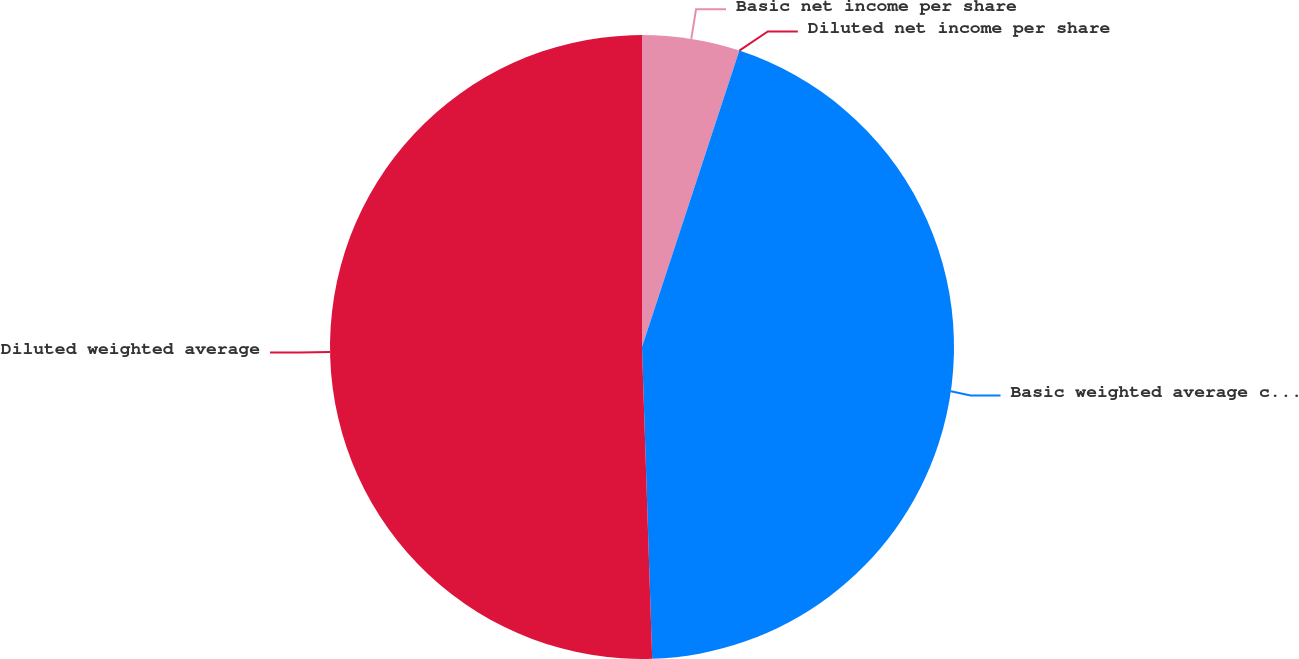Convert chart to OTSL. <chart><loc_0><loc_0><loc_500><loc_500><pie_chart><fcel>Basic net income per share<fcel>Diluted net income per share<fcel>Basic weighted average common<fcel>Diluted weighted average<nl><fcel>5.05%<fcel>0.0%<fcel>44.43%<fcel>50.52%<nl></chart> 